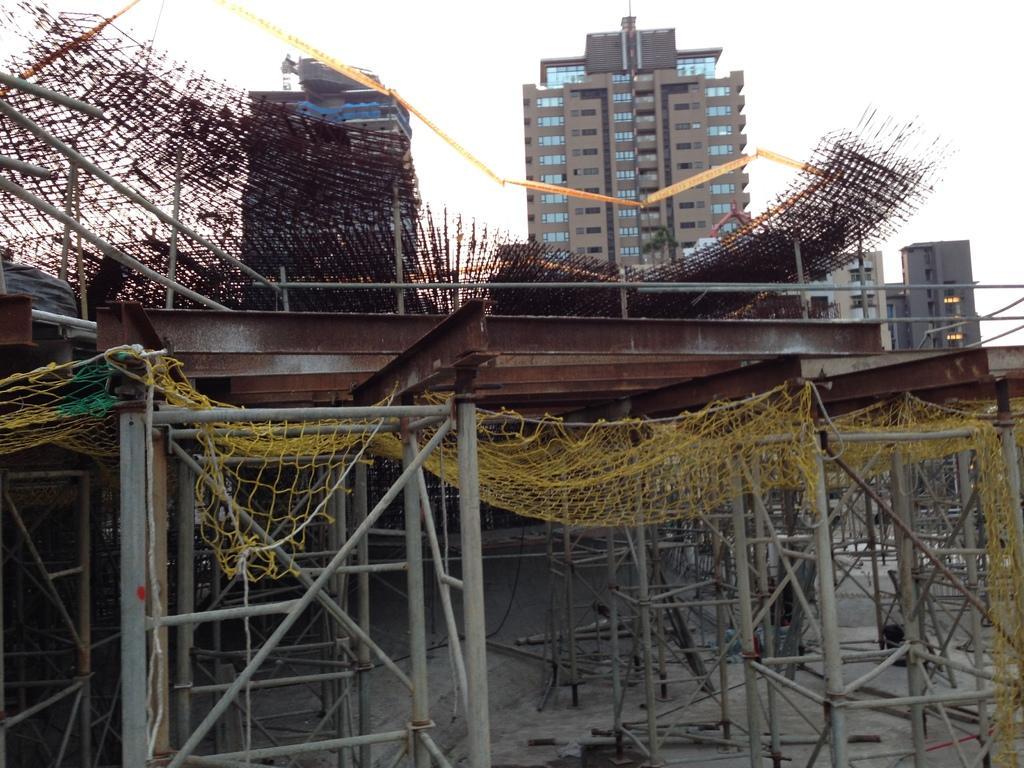In one or two sentences, can you explain what this image depicts? In the center of the image there are buildings. At the bottom we can see construction material and stands. There is a net. In the background there is sky. 